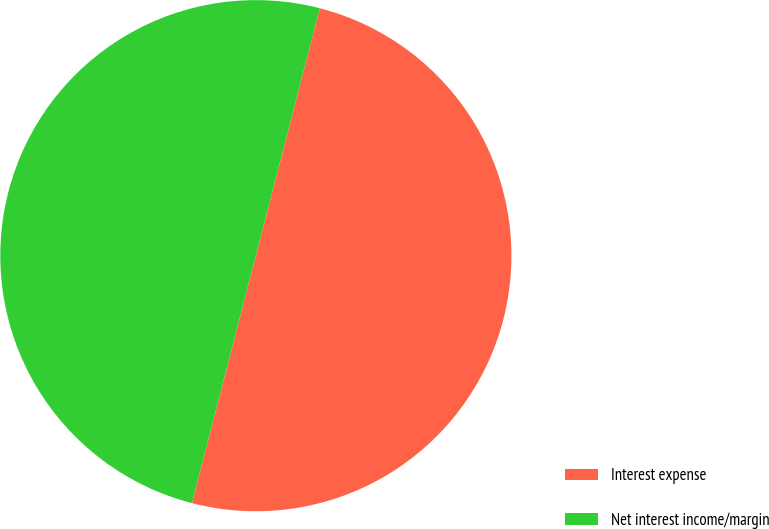Convert chart to OTSL. <chart><loc_0><loc_0><loc_500><loc_500><pie_chart><fcel>Interest expense<fcel>Net interest income/margin<nl><fcel>50.0%<fcel>50.0%<nl></chart> 